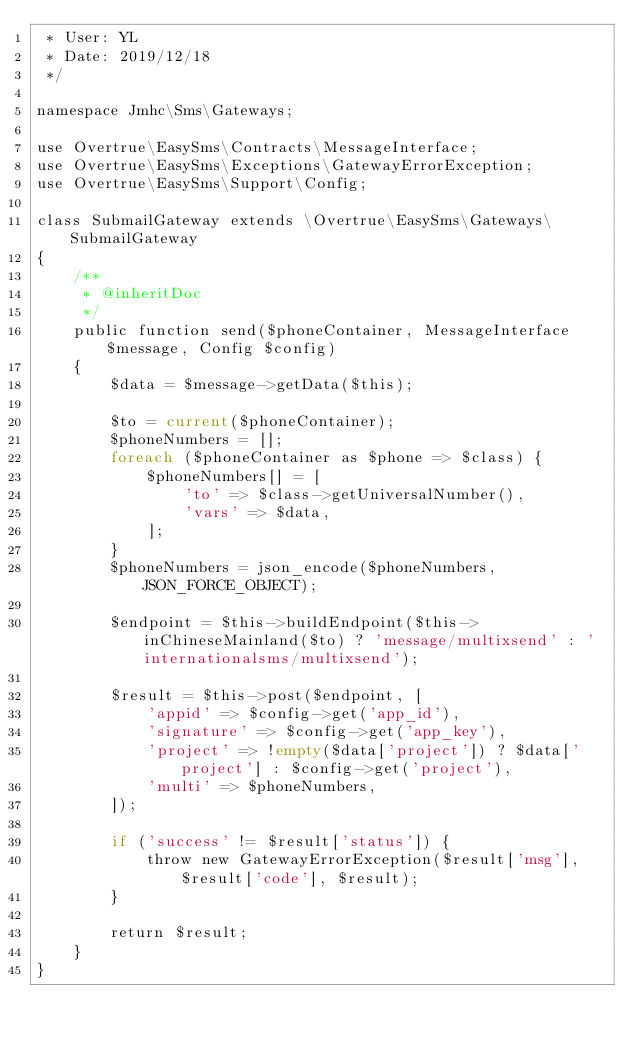Convert code to text. <code><loc_0><loc_0><loc_500><loc_500><_PHP_> * User: YL
 * Date: 2019/12/18
 */

namespace Jmhc\Sms\Gateways;

use Overtrue\EasySms\Contracts\MessageInterface;
use Overtrue\EasySms\Exceptions\GatewayErrorException;
use Overtrue\EasySms\Support\Config;

class SubmailGateway extends \Overtrue\EasySms\Gateways\SubmailGateway
{
    /**
     * @inheritDoc
     */
    public function send($phoneContainer, MessageInterface $message, Config $config)
    {
        $data = $message->getData($this);

        $to = current($phoneContainer);
        $phoneNumbers = [];
        foreach ($phoneContainer as $phone => $class) {
            $phoneNumbers[] = [
                'to' => $class->getUniversalNumber(),
                'vars' => $data,
            ];
        }
        $phoneNumbers = json_encode($phoneNumbers, JSON_FORCE_OBJECT);

        $endpoint = $this->buildEndpoint($this->inChineseMainland($to) ? 'message/multixsend' : 'internationalsms/multixsend');

        $result = $this->post($endpoint, [
            'appid' => $config->get('app_id'),
            'signature' => $config->get('app_key'),
            'project' => !empty($data['project']) ? $data['project'] : $config->get('project'),
            'multi' => $phoneNumbers,
        ]);

        if ('success' != $result['status']) {
            throw new GatewayErrorException($result['msg'], $result['code'], $result);
        }

        return $result;
    }
}
</code> 